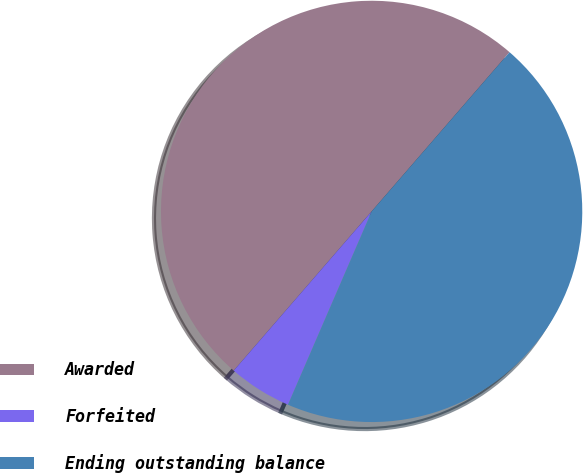Convert chart. <chart><loc_0><loc_0><loc_500><loc_500><pie_chart><fcel>Awarded<fcel>Forfeited<fcel>Ending outstanding balance<nl><fcel>50.0%<fcel>4.86%<fcel>45.14%<nl></chart> 